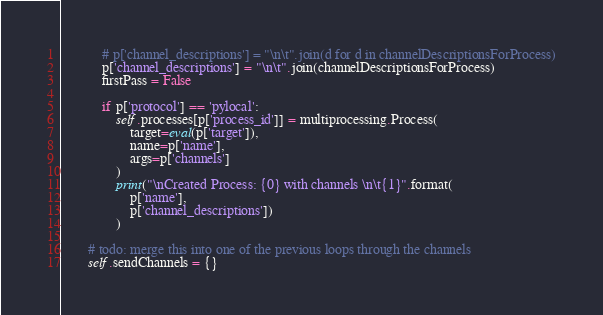<code> <loc_0><loc_0><loc_500><loc_500><_Python_>            # p['channel_descriptions'] = "\n\t".join(d for d in channelDescriptionsForProcess)
            p['channel_descriptions'] = "\n\t".join(channelDescriptionsForProcess)
            firstPass = False

            if p['protocol'] == 'pylocal':
                self.processes[p['process_id']] = multiprocessing.Process(
                    target=eval(p['target']),
                    name=p['name'],
                    args=p['channels']
                )
                print("\nCreated Process: {0} with channels \n\t{1}".format(
                    p['name'],
                    p['channel_descriptions'])
                )

        # todo: merge this into one of the previous loops through the channels
        self.sendChannels = {}</code> 